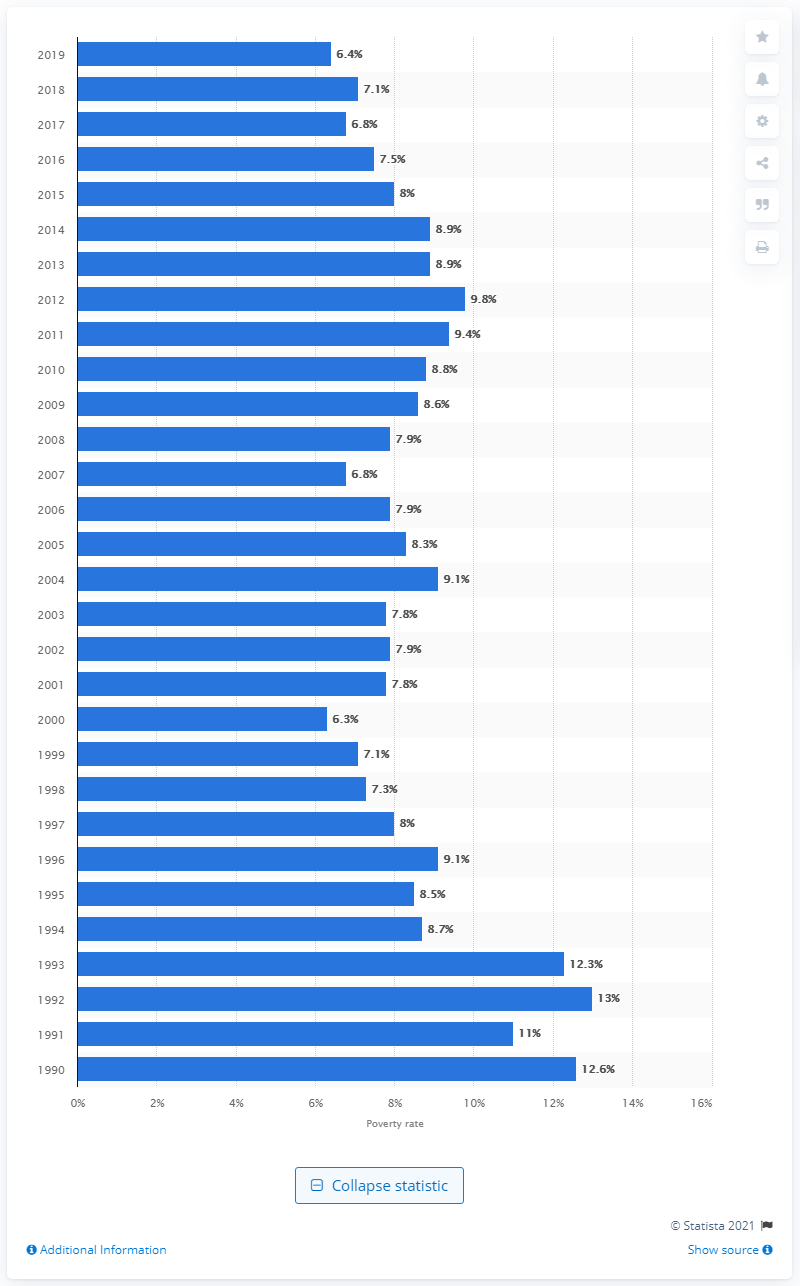Identify some key points in this picture. In 2019, 6.4% of Black married couple families were living below the poverty line, according to recent data. 